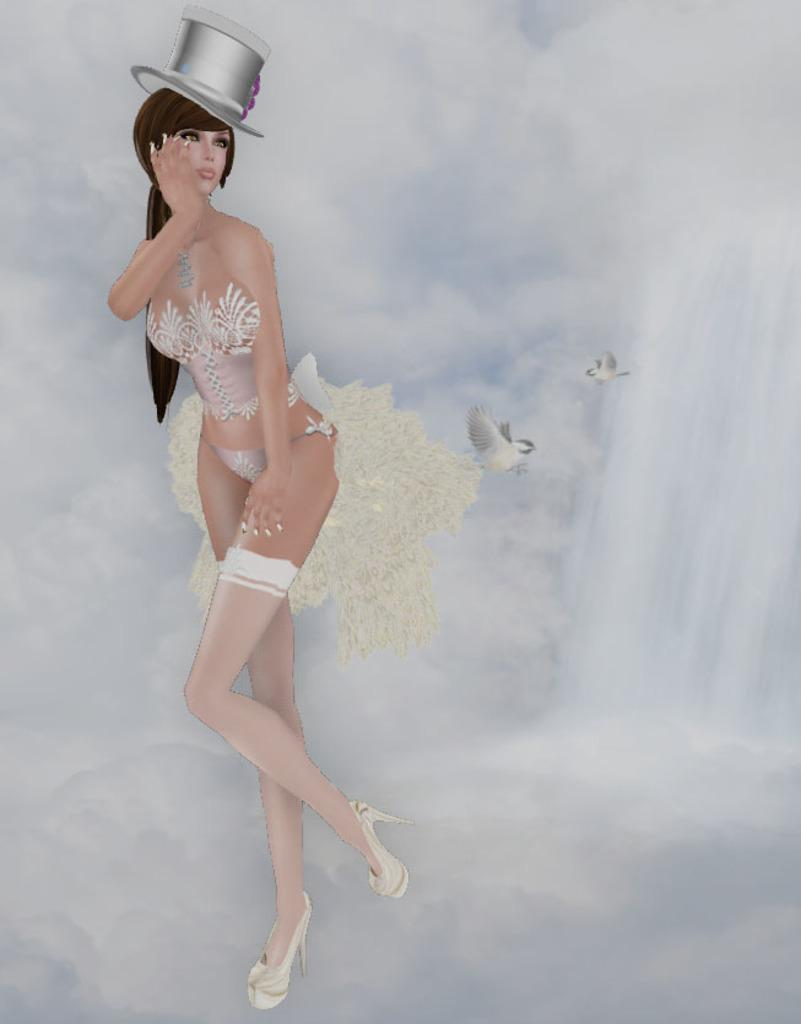What type of animals can be seen in the image? Birds can be seen in the image. Who else is present in the image besides the birds? There is a woman in the image. What part of the natural environment is visible in the image? The sky is visible in the image. What type of juice is the woman drinking in the image? There is no juice present in the image; it only features birds and a woman. 